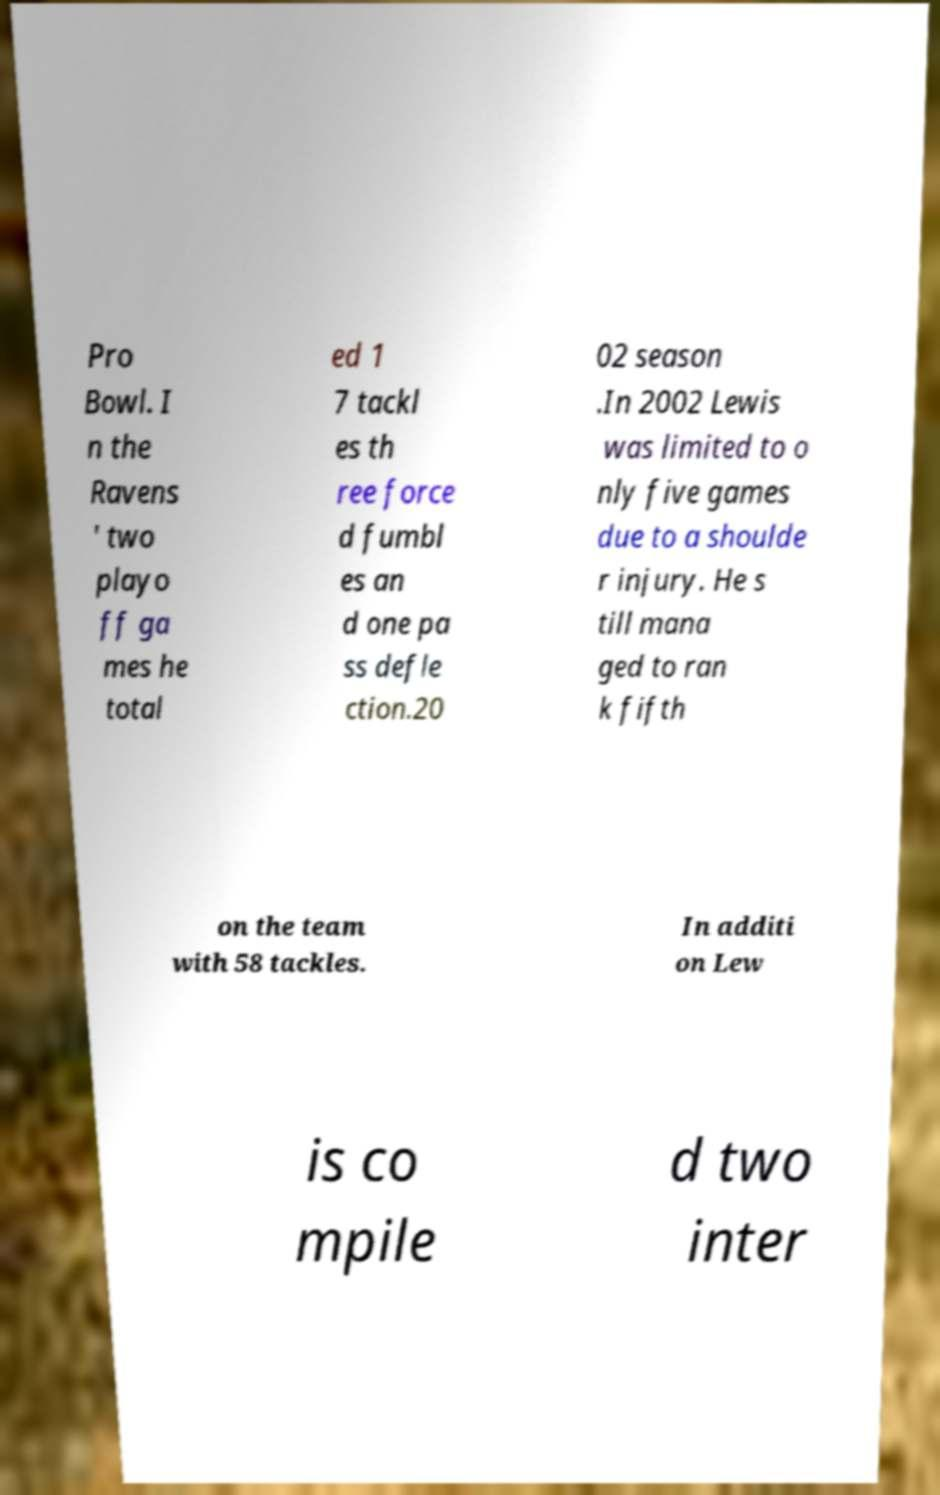Can you accurately transcribe the text from the provided image for me? Pro Bowl. I n the Ravens ' two playo ff ga mes he total ed 1 7 tackl es th ree force d fumbl es an d one pa ss defle ction.20 02 season .In 2002 Lewis was limited to o nly five games due to a shoulde r injury. He s till mana ged to ran k fifth on the team with 58 tackles. In additi on Lew is co mpile d two inter 